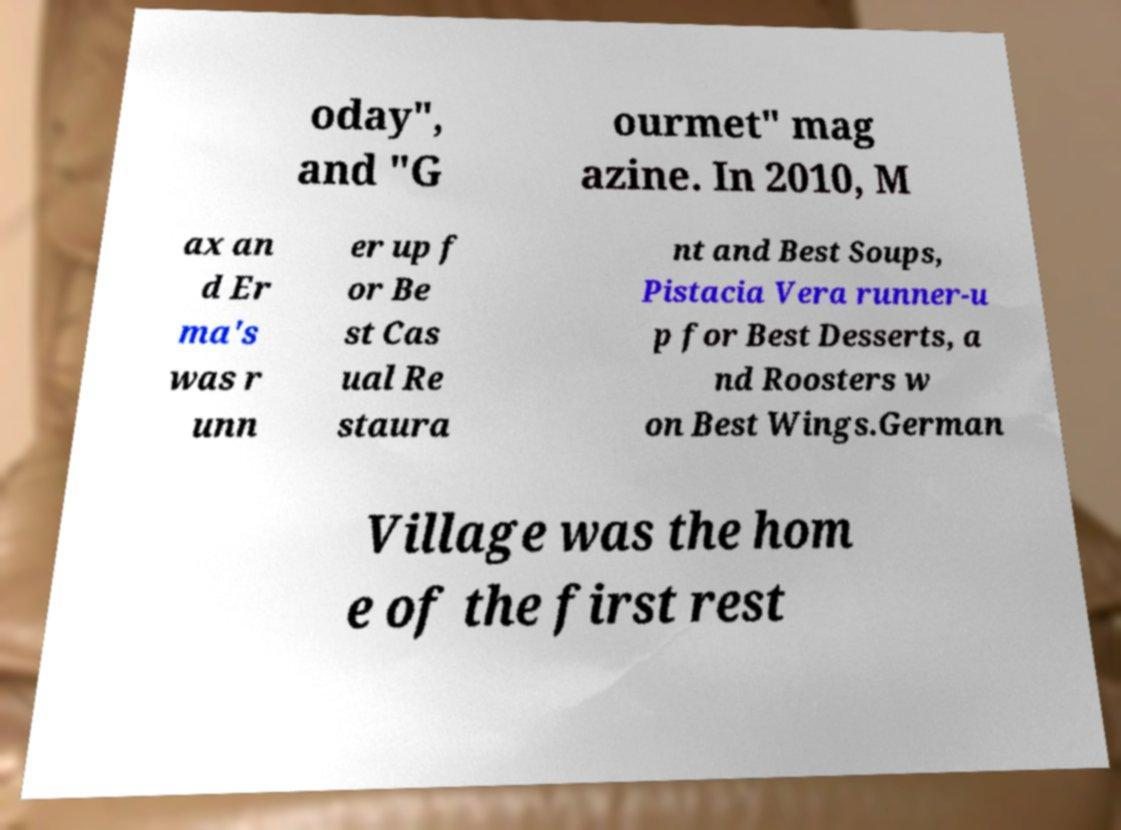I need the written content from this picture converted into text. Can you do that? oday", and "G ourmet" mag azine. In 2010, M ax an d Er ma's was r unn er up f or Be st Cas ual Re staura nt and Best Soups, Pistacia Vera runner-u p for Best Desserts, a nd Roosters w on Best Wings.German Village was the hom e of the first rest 